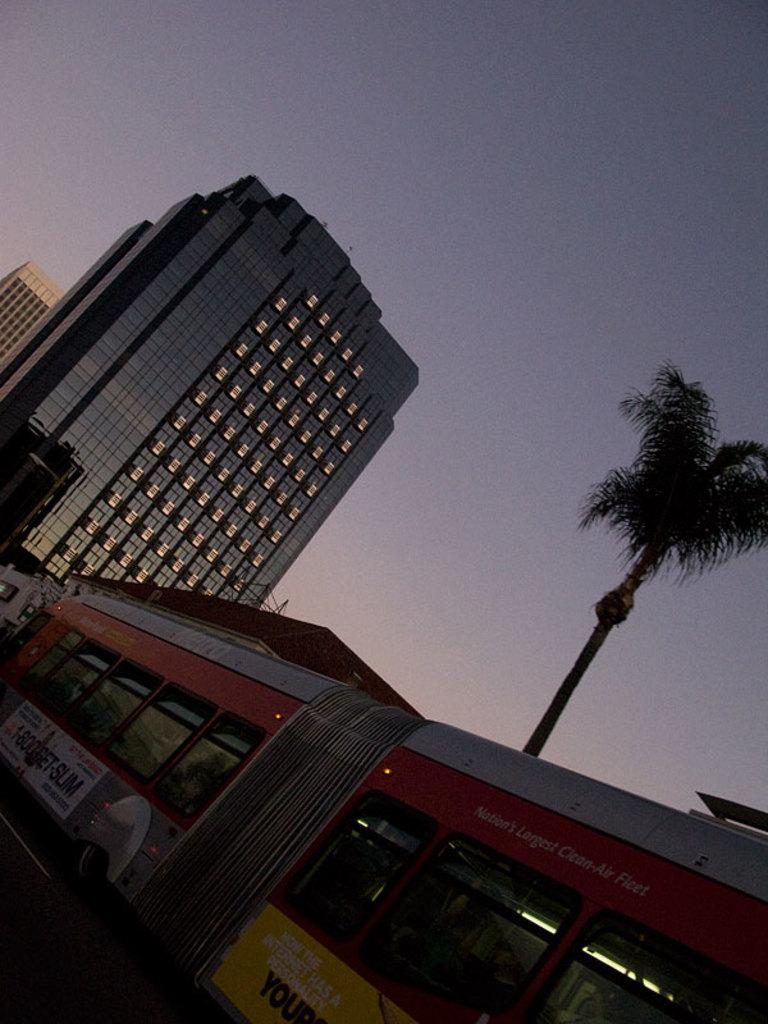What is the main subject of the image? There is a train in the image. What can be seen in the background of the image? There are trees and buildings in the background of the image. What is the color of the sky in the image? The sky is blue and white in color. Where is the goat grazing in the image? There is no goat present in the image, so it cannot be grazing anywhere. What type of scissors can be seen cutting the grass in the image? There are no scissors visible in the image, and no grass is being cut. 